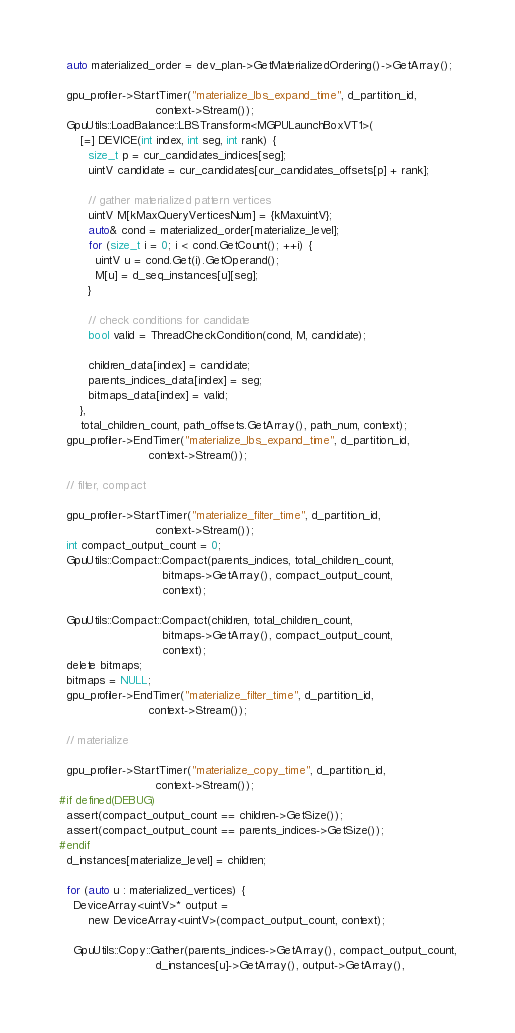<code> <loc_0><loc_0><loc_500><loc_500><_Cuda_>
  auto materialized_order = dev_plan->GetMaterializedOrdering()->GetArray();

  gpu_profiler->StartTimer("materialize_lbs_expand_time", d_partition_id,
                           context->Stream());
  GpuUtils::LoadBalance::LBSTransform<MGPULaunchBoxVT1>(
      [=] DEVICE(int index, int seg, int rank) {
        size_t p = cur_candidates_indices[seg];
        uintV candidate = cur_candidates[cur_candidates_offsets[p] + rank];

        // gather materialized pattern vertices
        uintV M[kMaxQueryVerticesNum] = {kMaxuintV};
        auto& cond = materialized_order[materialize_level];
        for (size_t i = 0; i < cond.GetCount(); ++i) {
          uintV u = cond.Get(i).GetOperand();
          M[u] = d_seq_instances[u][seg];
        }

        // check conditions for candidate
        bool valid = ThreadCheckCondition(cond, M, candidate);

        children_data[index] = candidate;
        parents_indices_data[index] = seg;
        bitmaps_data[index] = valid;
      },
      total_children_count, path_offsets.GetArray(), path_num, context);
  gpu_profiler->EndTimer("materialize_lbs_expand_time", d_partition_id,
                         context->Stream());

  // filter, compact

  gpu_profiler->StartTimer("materialize_filter_time", d_partition_id,
                           context->Stream());
  int compact_output_count = 0;
  GpuUtils::Compact::Compact(parents_indices, total_children_count,
                             bitmaps->GetArray(), compact_output_count,
                             context);

  GpuUtils::Compact::Compact(children, total_children_count,
                             bitmaps->GetArray(), compact_output_count,
                             context);
  delete bitmaps;
  bitmaps = NULL;
  gpu_profiler->EndTimer("materialize_filter_time", d_partition_id,
                         context->Stream());

  // materialize

  gpu_profiler->StartTimer("materialize_copy_time", d_partition_id,
                           context->Stream());
#if defined(DEBUG)
  assert(compact_output_count == children->GetSize());
  assert(compact_output_count == parents_indices->GetSize());
#endif
  d_instances[materialize_level] = children;

  for (auto u : materialized_vertices) {
    DeviceArray<uintV>* output =
        new DeviceArray<uintV>(compact_output_count, context);

    GpuUtils::Copy::Gather(parents_indices->GetArray(), compact_output_count,
                           d_instances[u]->GetArray(), output->GetArray(),</code> 